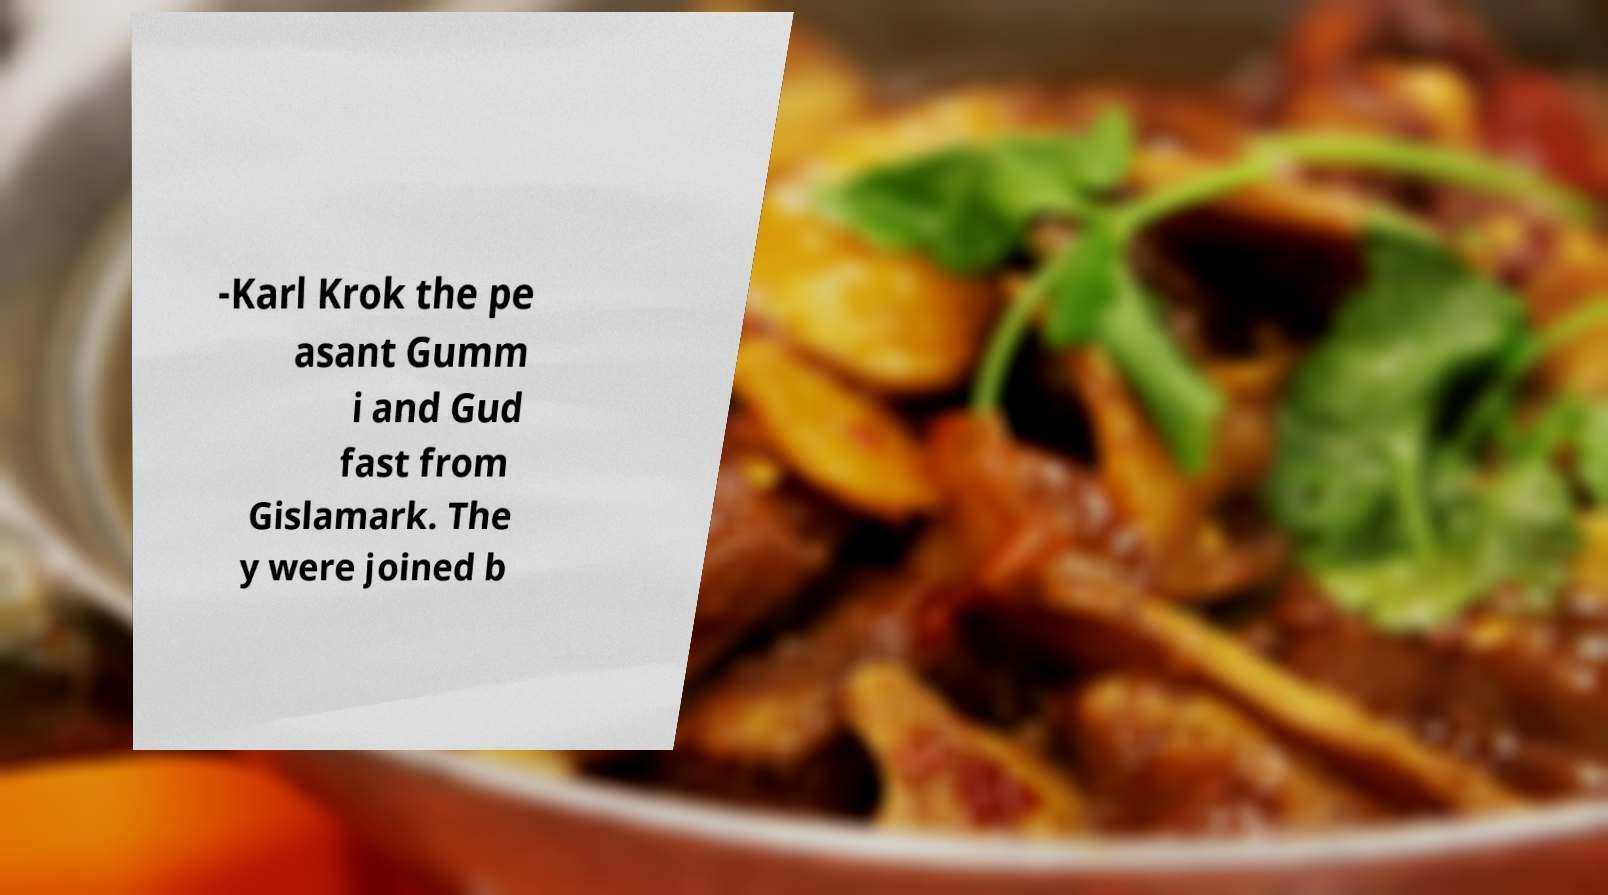For documentation purposes, I need the text within this image transcribed. Could you provide that? -Karl Krok the pe asant Gumm i and Gud fast from Gislamark. The y were joined b 